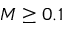Convert formula to latex. <formula><loc_0><loc_0><loc_500><loc_500>M \geq 0 . 1</formula> 